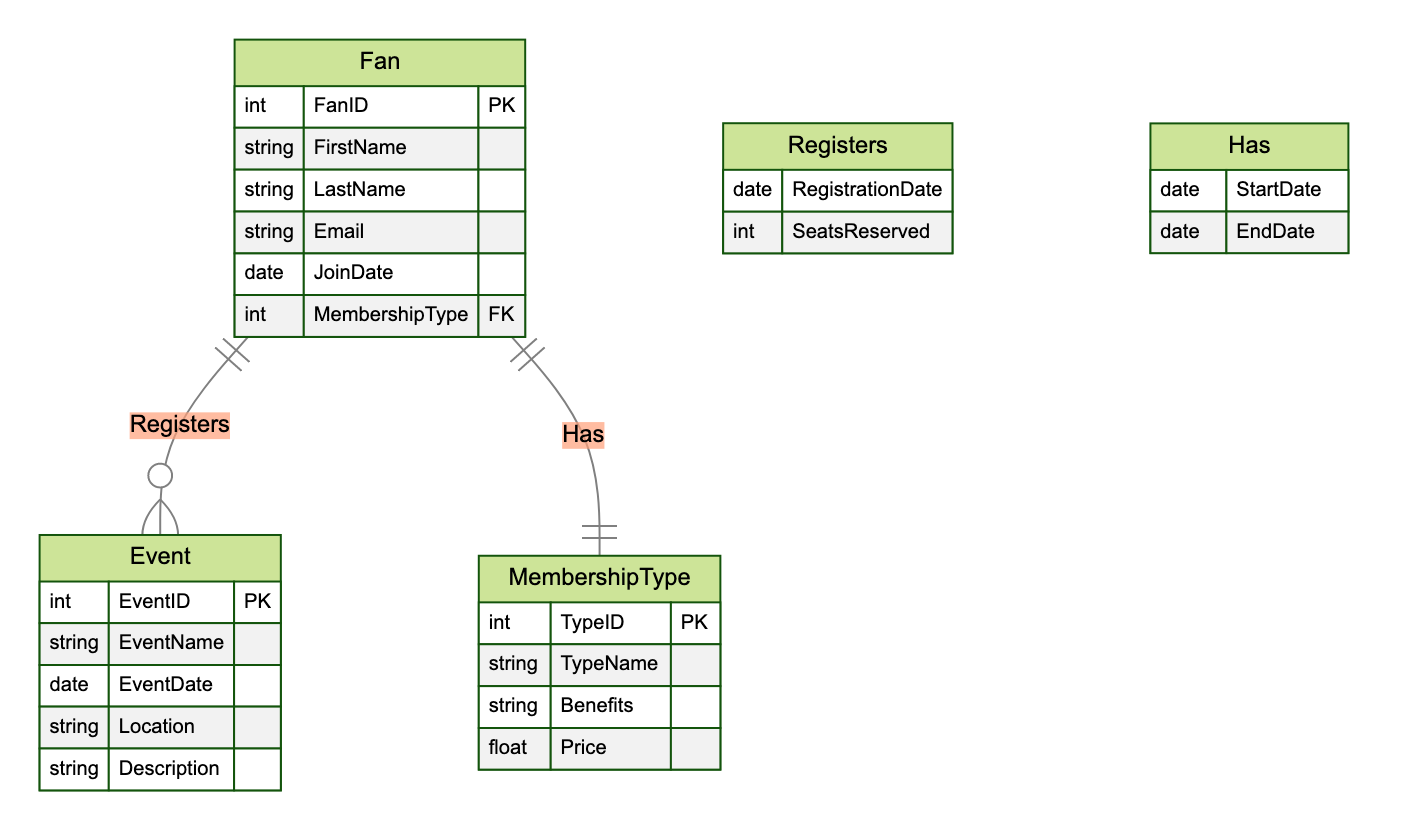What is the primary key of the Fan entity? The primary key of the Fan entity is indicated as "FanID" in the diagram, which uniquely identifies each Fan.
Answer: FanID How many attributes does the MembershipType entity have? The MembershipType entity has four attributes listed: "TypeID," "TypeName," "Benefits," and "Price." Counting these gives a total of four attributes.
Answer: 4 What relationship connects Fan and Event? The relationship that connects Fan and Event is named "Registers," indicating that fans can register for events.
Answer: Registers What is the type of the relationship between Fan and MembershipType? The relationship between Fan and MembershipType is a one-to-one relationship, denoted by the symbols on the diagram: one Fan can have one MembershipType.
Answer: One-to-One What is the price attribute's data type in MembershipType? The price attribute in MembershipType is shown as a float, indicating it can contain decimal values for pricing details.
Answer: Float What benefits does a Fan receive from MembershipType? The benefits received from MembershipType are specified in the "Benefits" attribute, which can vary depending on the type of membership chosen by the fan.
Answer: Benefits How many entities are represented in the diagram? There are three entities represented in the diagram: Fan, Event, and MembershipType. Summing these gives a total of three entities.
Answer: 3 What does the attribute "SeatsReserved" represent in the Registers relationship? The attribute "SeatsReserved" in the Registers relationship indicates the number of seats that a fan has reserved for a specific event they are registering for.
Answer: Number of seats What additional attributes are associated with the Registers relationship? The Registers relationship includes two additional attributes: "RegistrationDate" and "SeatsReserved," which provide information about when the fan registered and how many seats were reserved.
Answer: RegistrationDate and SeatsReserved 